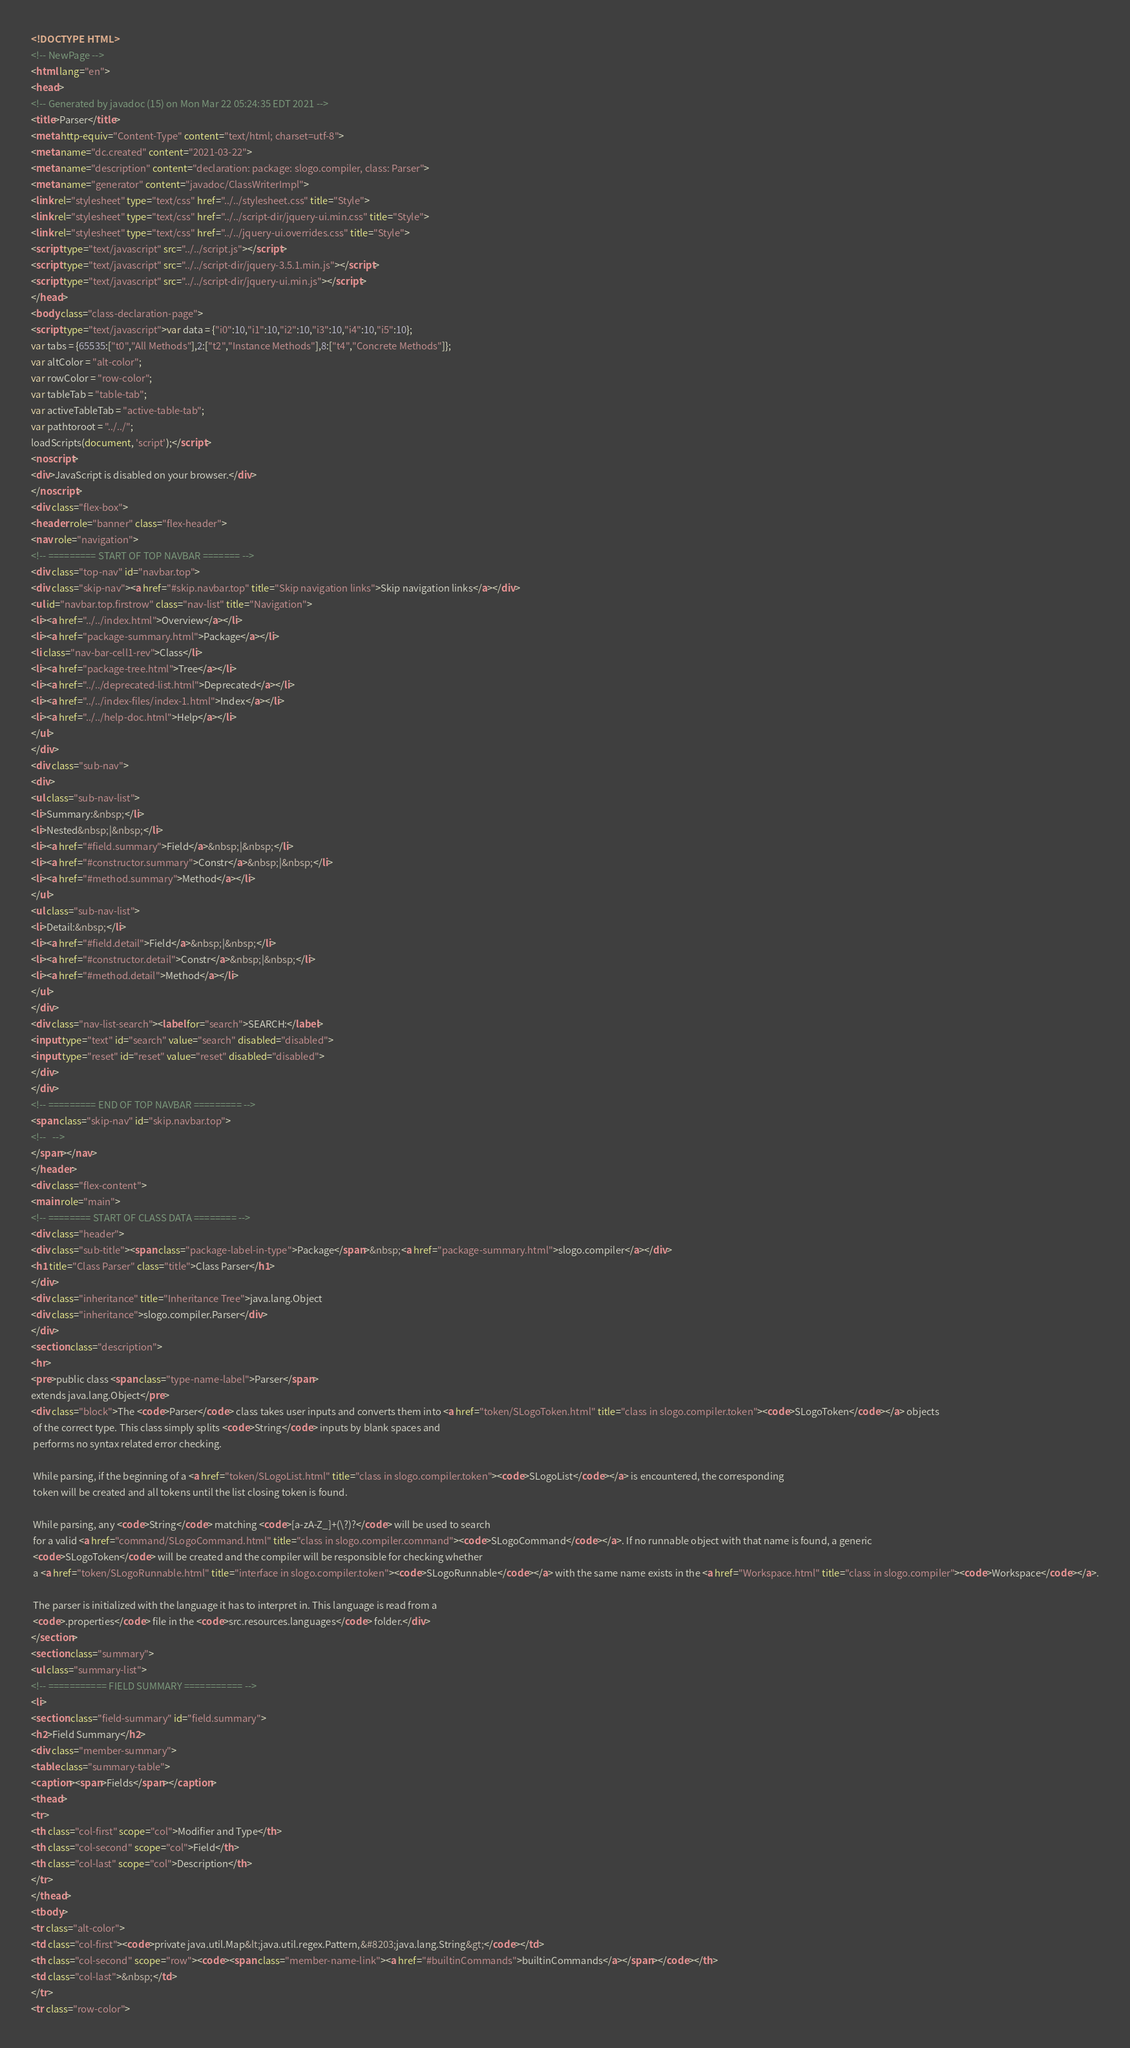Convert code to text. <code><loc_0><loc_0><loc_500><loc_500><_HTML_><!DOCTYPE HTML>
<!-- NewPage -->
<html lang="en">
<head>
<!-- Generated by javadoc (15) on Mon Mar 22 05:24:35 EDT 2021 -->
<title>Parser</title>
<meta http-equiv="Content-Type" content="text/html; charset=utf-8">
<meta name="dc.created" content="2021-03-22">
<meta name="description" content="declaration: package: slogo.compiler, class: Parser">
<meta name="generator" content="javadoc/ClassWriterImpl">
<link rel="stylesheet" type="text/css" href="../../stylesheet.css" title="Style">
<link rel="stylesheet" type="text/css" href="../../script-dir/jquery-ui.min.css" title="Style">
<link rel="stylesheet" type="text/css" href="../../jquery-ui.overrides.css" title="Style">
<script type="text/javascript" src="../../script.js"></script>
<script type="text/javascript" src="../../script-dir/jquery-3.5.1.min.js"></script>
<script type="text/javascript" src="../../script-dir/jquery-ui.min.js"></script>
</head>
<body class="class-declaration-page">
<script type="text/javascript">var data = {"i0":10,"i1":10,"i2":10,"i3":10,"i4":10,"i5":10};
var tabs = {65535:["t0","All Methods"],2:["t2","Instance Methods"],8:["t4","Concrete Methods"]};
var altColor = "alt-color";
var rowColor = "row-color";
var tableTab = "table-tab";
var activeTableTab = "active-table-tab";
var pathtoroot = "../../";
loadScripts(document, 'script');</script>
<noscript>
<div>JavaScript is disabled on your browser.</div>
</noscript>
<div class="flex-box">
<header role="banner" class="flex-header">
<nav role="navigation">
<!-- ========= START OF TOP NAVBAR ======= -->
<div class="top-nav" id="navbar.top">
<div class="skip-nav"><a href="#skip.navbar.top" title="Skip navigation links">Skip navigation links</a></div>
<ul id="navbar.top.firstrow" class="nav-list" title="Navigation">
<li><a href="../../index.html">Overview</a></li>
<li><a href="package-summary.html">Package</a></li>
<li class="nav-bar-cell1-rev">Class</li>
<li><a href="package-tree.html">Tree</a></li>
<li><a href="../../deprecated-list.html">Deprecated</a></li>
<li><a href="../../index-files/index-1.html">Index</a></li>
<li><a href="../../help-doc.html">Help</a></li>
</ul>
</div>
<div class="sub-nav">
<div>
<ul class="sub-nav-list">
<li>Summary:&nbsp;</li>
<li>Nested&nbsp;|&nbsp;</li>
<li><a href="#field.summary">Field</a>&nbsp;|&nbsp;</li>
<li><a href="#constructor.summary">Constr</a>&nbsp;|&nbsp;</li>
<li><a href="#method.summary">Method</a></li>
</ul>
<ul class="sub-nav-list">
<li>Detail:&nbsp;</li>
<li><a href="#field.detail">Field</a>&nbsp;|&nbsp;</li>
<li><a href="#constructor.detail">Constr</a>&nbsp;|&nbsp;</li>
<li><a href="#method.detail">Method</a></li>
</ul>
</div>
<div class="nav-list-search"><label for="search">SEARCH:</label>
<input type="text" id="search" value="search" disabled="disabled">
<input type="reset" id="reset" value="reset" disabled="disabled">
</div>
</div>
<!-- ========= END OF TOP NAVBAR ========= -->
<span class="skip-nav" id="skip.navbar.top">
<!--   -->
</span></nav>
</header>
<div class="flex-content">
<main role="main">
<!-- ======== START OF CLASS DATA ======== -->
<div class="header">
<div class="sub-title"><span class="package-label-in-type">Package</span>&nbsp;<a href="package-summary.html">slogo.compiler</a></div>
<h1 title="Class Parser" class="title">Class Parser</h1>
</div>
<div class="inheritance" title="Inheritance Tree">java.lang.Object
<div class="inheritance">slogo.compiler.Parser</div>
</div>
<section class="description">
<hr>
<pre>public class <span class="type-name-label">Parser</span>
extends java.lang.Object</pre>
<div class="block">The <code>Parser</code> class takes user inputs and converts them into <a href="token/SLogoToken.html" title="class in slogo.compiler.token"><code>SLogoToken</code></a> objects
 of the correct type. This class simply splits <code>String</code> inputs by blank spaces and
 performs no syntax related error checking.

 While parsing, if the beginning of a <a href="token/SLogoList.html" title="class in slogo.compiler.token"><code>SLogoList</code></a> is encountered, the corresponding
 token will be created and all tokens until the list closing token is found.

 While parsing, any <code>String</code> matching <code>[a-zA-Z_]+(\?)?</code> will be used to search
 for a valid <a href="command/SLogoCommand.html" title="class in slogo.compiler.command"><code>SLogoCommand</code></a>. If no runnable object with that name is found, a generic
 <code>SLogoToken</code> will be created and the compiler will be responsible for checking whether
 a <a href="token/SLogoRunnable.html" title="interface in slogo.compiler.token"><code>SLogoRunnable</code></a> with the same name exists in the <a href="Workspace.html" title="class in slogo.compiler"><code>Workspace</code></a>.

 The parser is initialized with the language it has to interpret in. This language is read from a
 <code>.properties</code> file in the <code>src.resources.languages</code> folder.</div>
</section>
<section class="summary">
<ul class="summary-list">
<!-- =========== FIELD SUMMARY =========== -->
<li>
<section class="field-summary" id="field.summary">
<h2>Field Summary</h2>
<div class="member-summary">
<table class="summary-table">
<caption><span>Fields</span></caption>
<thead>
<tr>
<th class="col-first" scope="col">Modifier and Type</th>
<th class="col-second" scope="col">Field</th>
<th class="col-last" scope="col">Description</th>
</tr>
</thead>
<tbody>
<tr class="alt-color">
<td class="col-first"><code>private java.util.Map&lt;java.util.regex.Pattern,&#8203;java.lang.String&gt;</code></td>
<th class="col-second" scope="row"><code><span class="member-name-link"><a href="#builtinCommands">builtinCommands</a></span></code></th>
<td class="col-last">&nbsp;</td>
</tr>
<tr class="row-color"></code> 